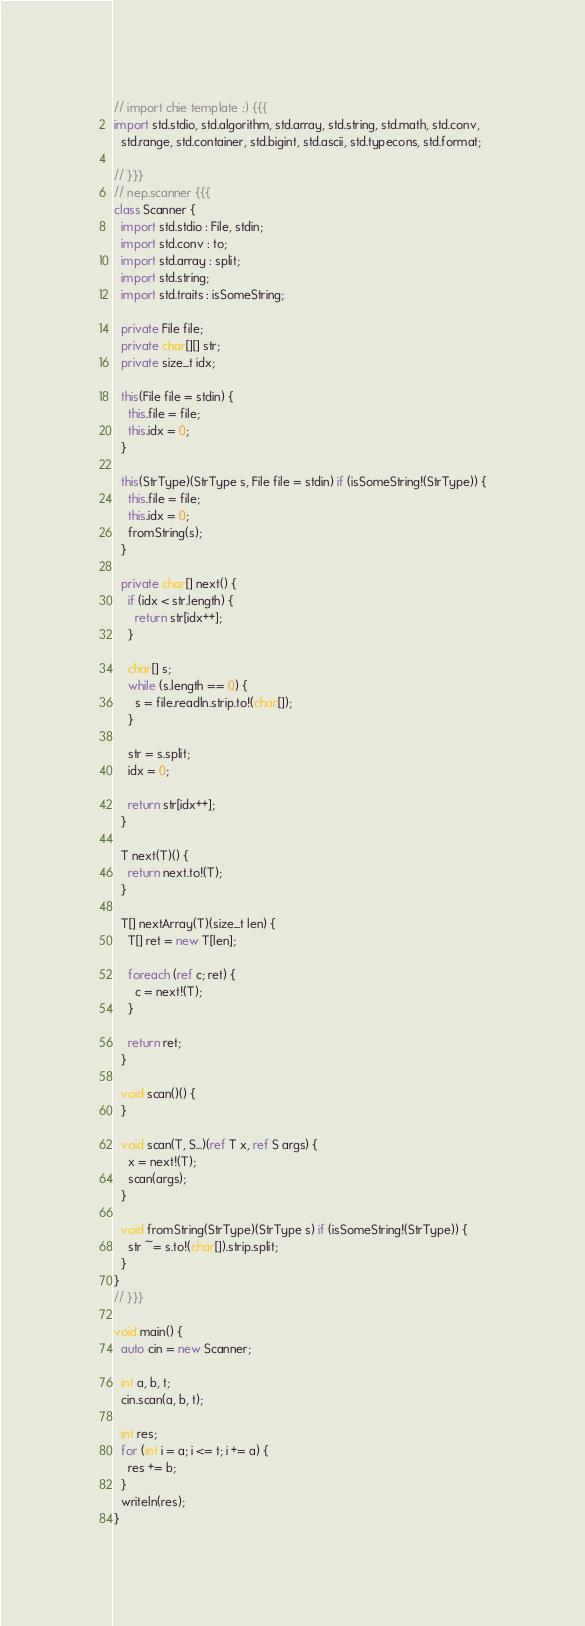<code> <loc_0><loc_0><loc_500><loc_500><_D_>// import chie template :) {{{
import std.stdio, std.algorithm, std.array, std.string, std.math, std.conv,
  std.range, std.container, std.bigint, std.ascii, std.typecons, std.format;

// }}}
// nep.scanner {{{
class Scanner {
  import std.stdio : File, stdin;
  import std.conv : to;
  import std.array : split;
  import std.string;
  import std.traits : isSomeString;

  private File file;
  private char[][] str;
  private size_t idx;

  this(File file = stdin) {
    this.file = file;
    this.idx = 0;
  }

  this(StrType)(StrType s, File file = stdin) if (isSomeString!(StrType)) {
    this.file = file;
    this.idx = 0;
    fromString(s);
  }

  private char[] next() {
    if (idx < str.length) {
      return str[idx++];
    }

    char[] s;
    while (s.length == 0) {
      s = file.readln.strip.to!(char[]);
    }

    str = s.split;
    idx = 0;

    return str[idx++];
  }

  T next(T)() {
    return next.to!(T);
  }

  T[] nextArray(T)(size_t len) {
    T[] ret = new T[len];

    foreach (ref c; ret) {
      c = next!(T);
    }

    return ret;
  }

  void scan()() {
  }

  void scan(T, S...)(ref T x, ref S args) {
    x = next!(T);
    scan(args);
  }

  void fromString(StrType)(StrType s) if (isSomeString!(StrType)) {
    str ~= s.to!(char[]).strip.split;
  }
}
// }}}

void main() {
  auto cin = new Scanner;
  
  int a, b, t;
  cin.scan(a, b, t);

  int res;
  for (int i = a; i <= t; i += a) {
    res += b;
  }
  writeln(res);
}
</code> 